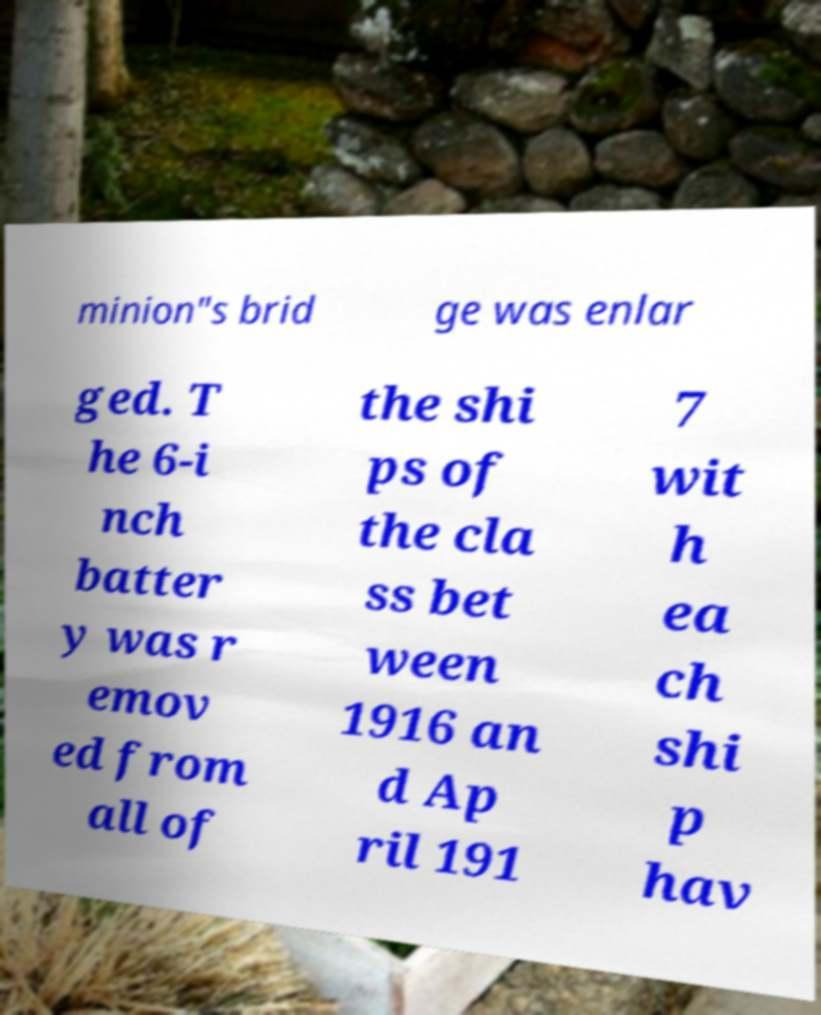Could you extract and type out the text from this image? minion"s brid ge was enlar ged. T he 6-i nch batter y was r emov ed from all of the shi ps of the cla ss bet ween 1916 an d Ap ril 191 7 wit h ea ch shi p hav 